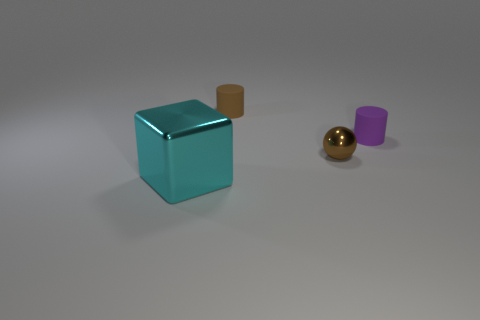Is there any other thing that is made of the same material as the purple cylinder?
Give a very brief answer. Yes. Is the number of big cubes behind the block greater than the number of cyan matte things?
Provide a succinct answer. No. Does the big metal block have the same color as the small ball?
Make the answer very short. No. How many other small things are the same shape as the purple thing?
Offer a terse response. 1. What size is the ball that is made of the same material as the big cyan block?
Offer a terse response. Small. What color is the object that is to the left of the small ball and behind the cyan metallic thing?
Ensure brevity in your answer.  Brown. How many matte things have the same size as the cyan metal cube?
Your answer should be very brief. 0. The matte cylinder that is the same color as the small metal ball is what size?
Your answer should be compact. Small. What size is the thing that is both to the left of the tiny brown sphere and right of the big cyan thing?
Ensure brevity in your answer.  Small. There is a metal object to the left of the shiny thing behind the big object; what number of cubes are behind it?
Make the answer very short. 0. 